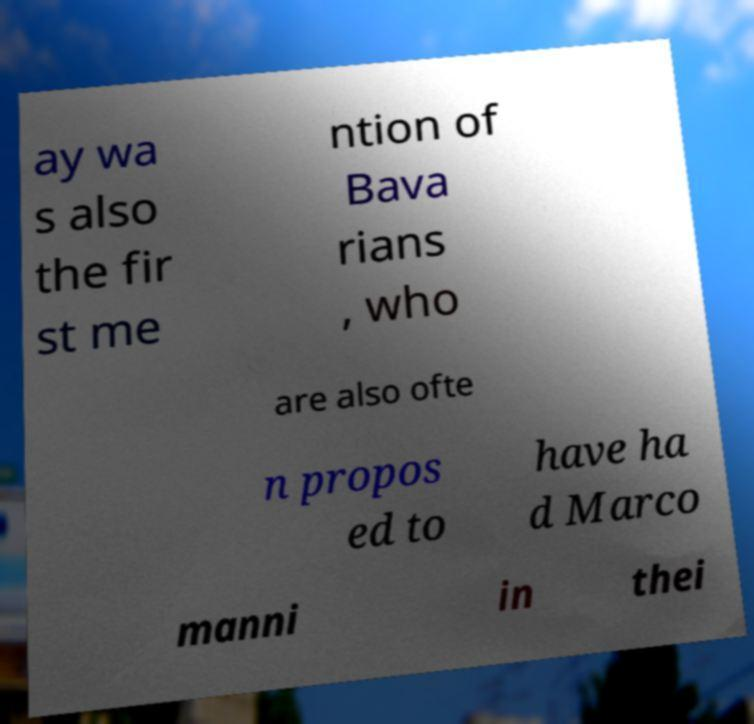Please identify and transcribe the text found in this image. ay wa s also the fir st me ntion of Bava rians , who are also ofte n propos ed to have ha d Marco manni in thei 